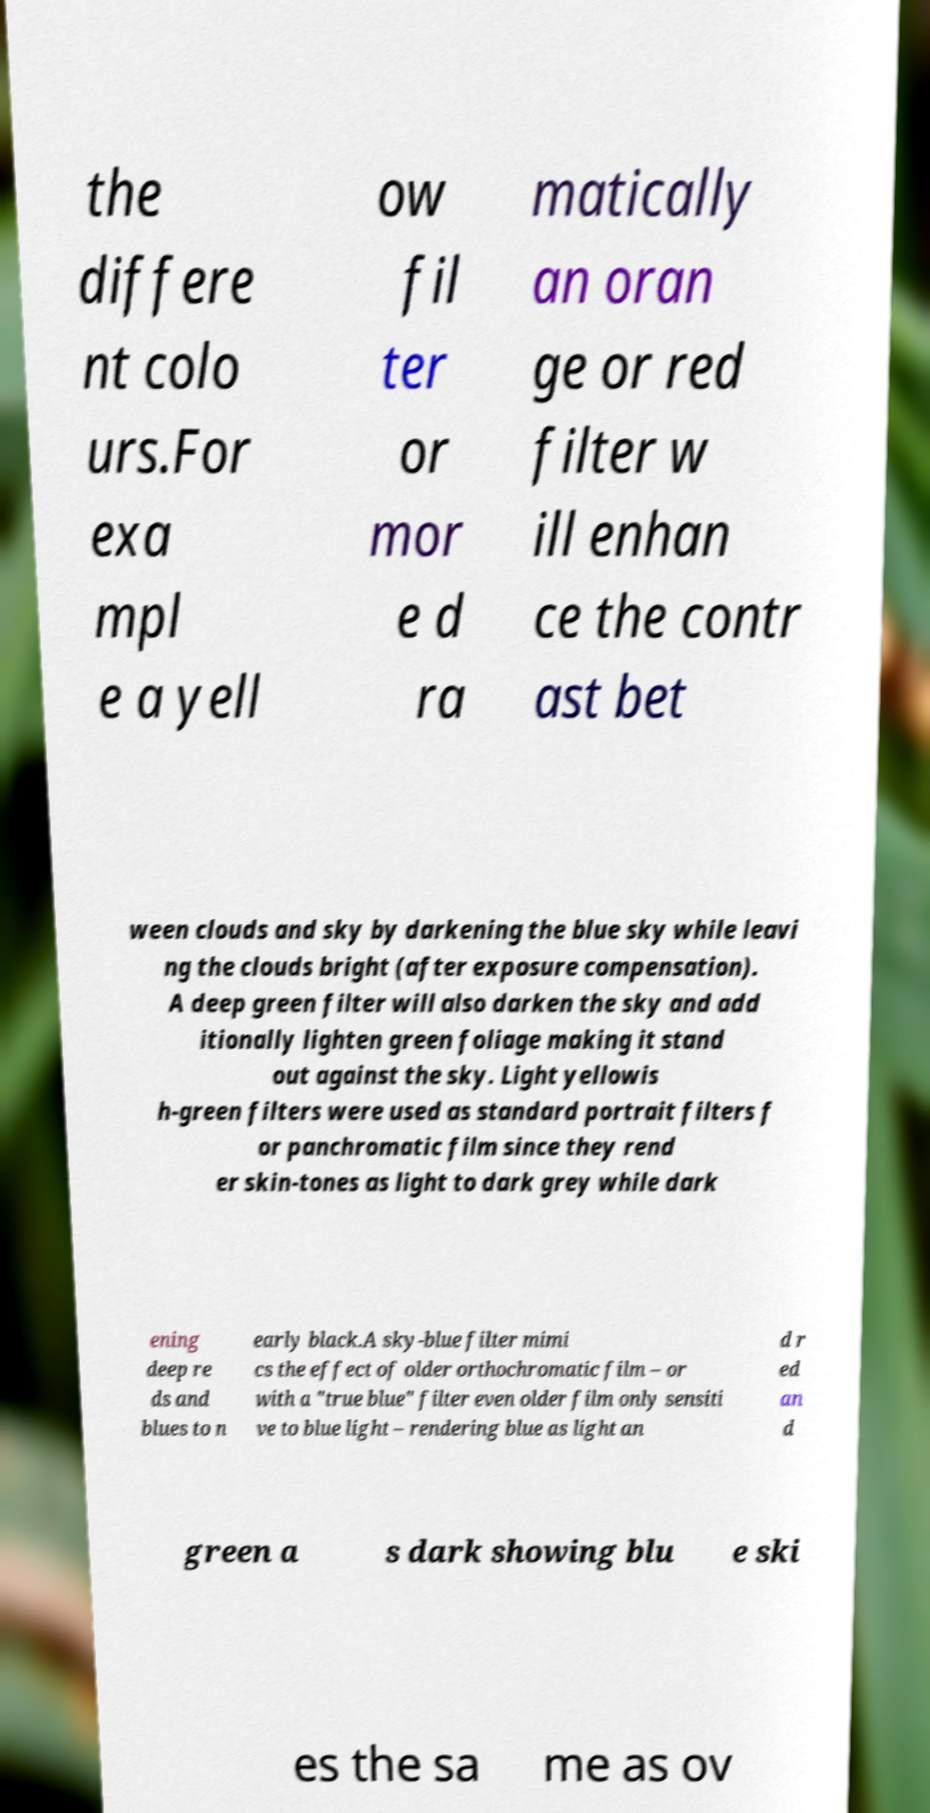Could you assist in decoding the text presented in this image and type it out clearly? the differe nt colo urs.For exa mpl e a yell ow fil ter or mor e d ra matically an oran ge or red filter w ill enhan ce the contr ast bet ween clouds and sky by darkening the blue sky while leavi ng the clouds bright (after exposure compensation). A deep green filter will also darken the sky and add itionally lighten green foliage making it stand out against the sky. Light yellowis h-green filters were used as standard portrait filters f or panchromatic film since they rend er skin-tones as light to dark grey while dark ening deep re ds and blues to n early black.A sky-blue filter mimi cs the effect of older orthochromatic film – or with a "true blue" filter even older film only sensiti ve to blue light – rendering blue as light an d r ed an d green a s dark showing blu e ski es the sa me as ov 